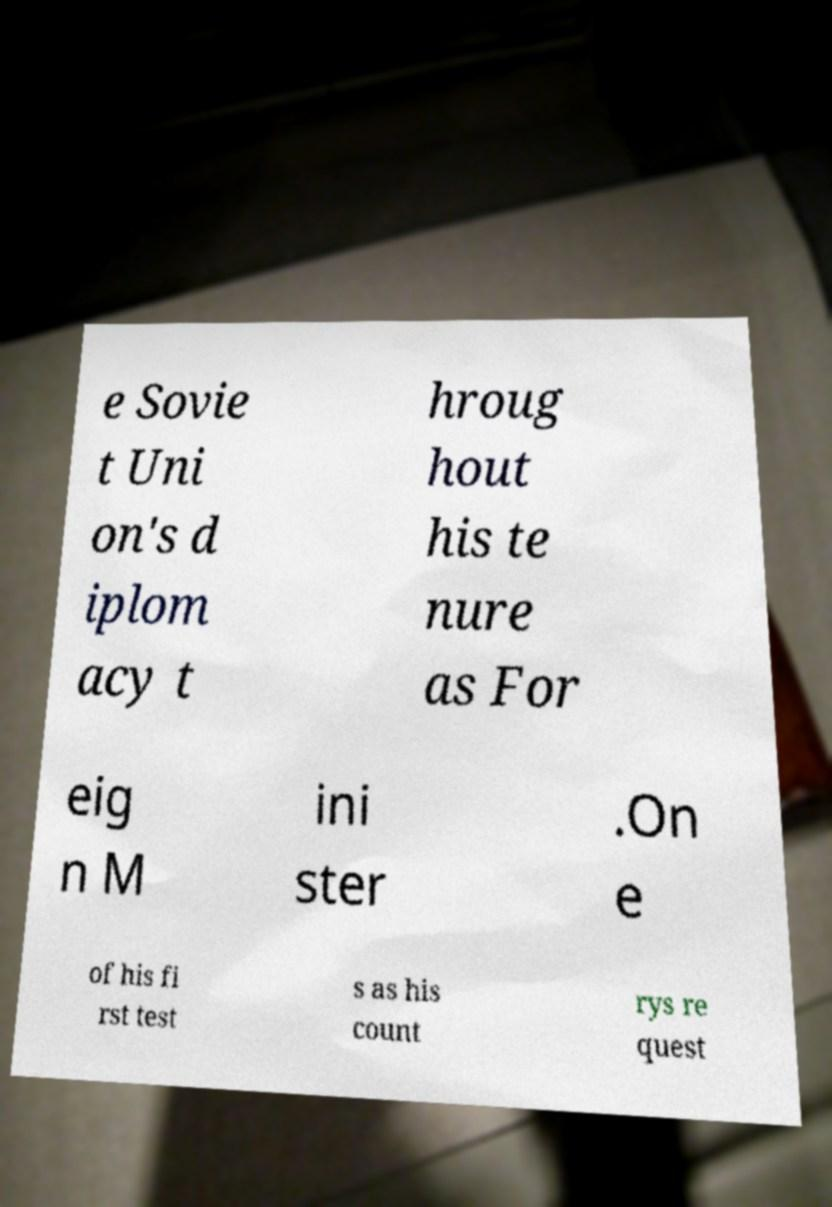There's text embedded in this image that I need extracted. Can you transcribe it verbatim? e Sovie t Uni on's d iplom acy t hroug hout his te nure as For eig n M ini ster .On e of his fi rst test s as his count rys re quest 